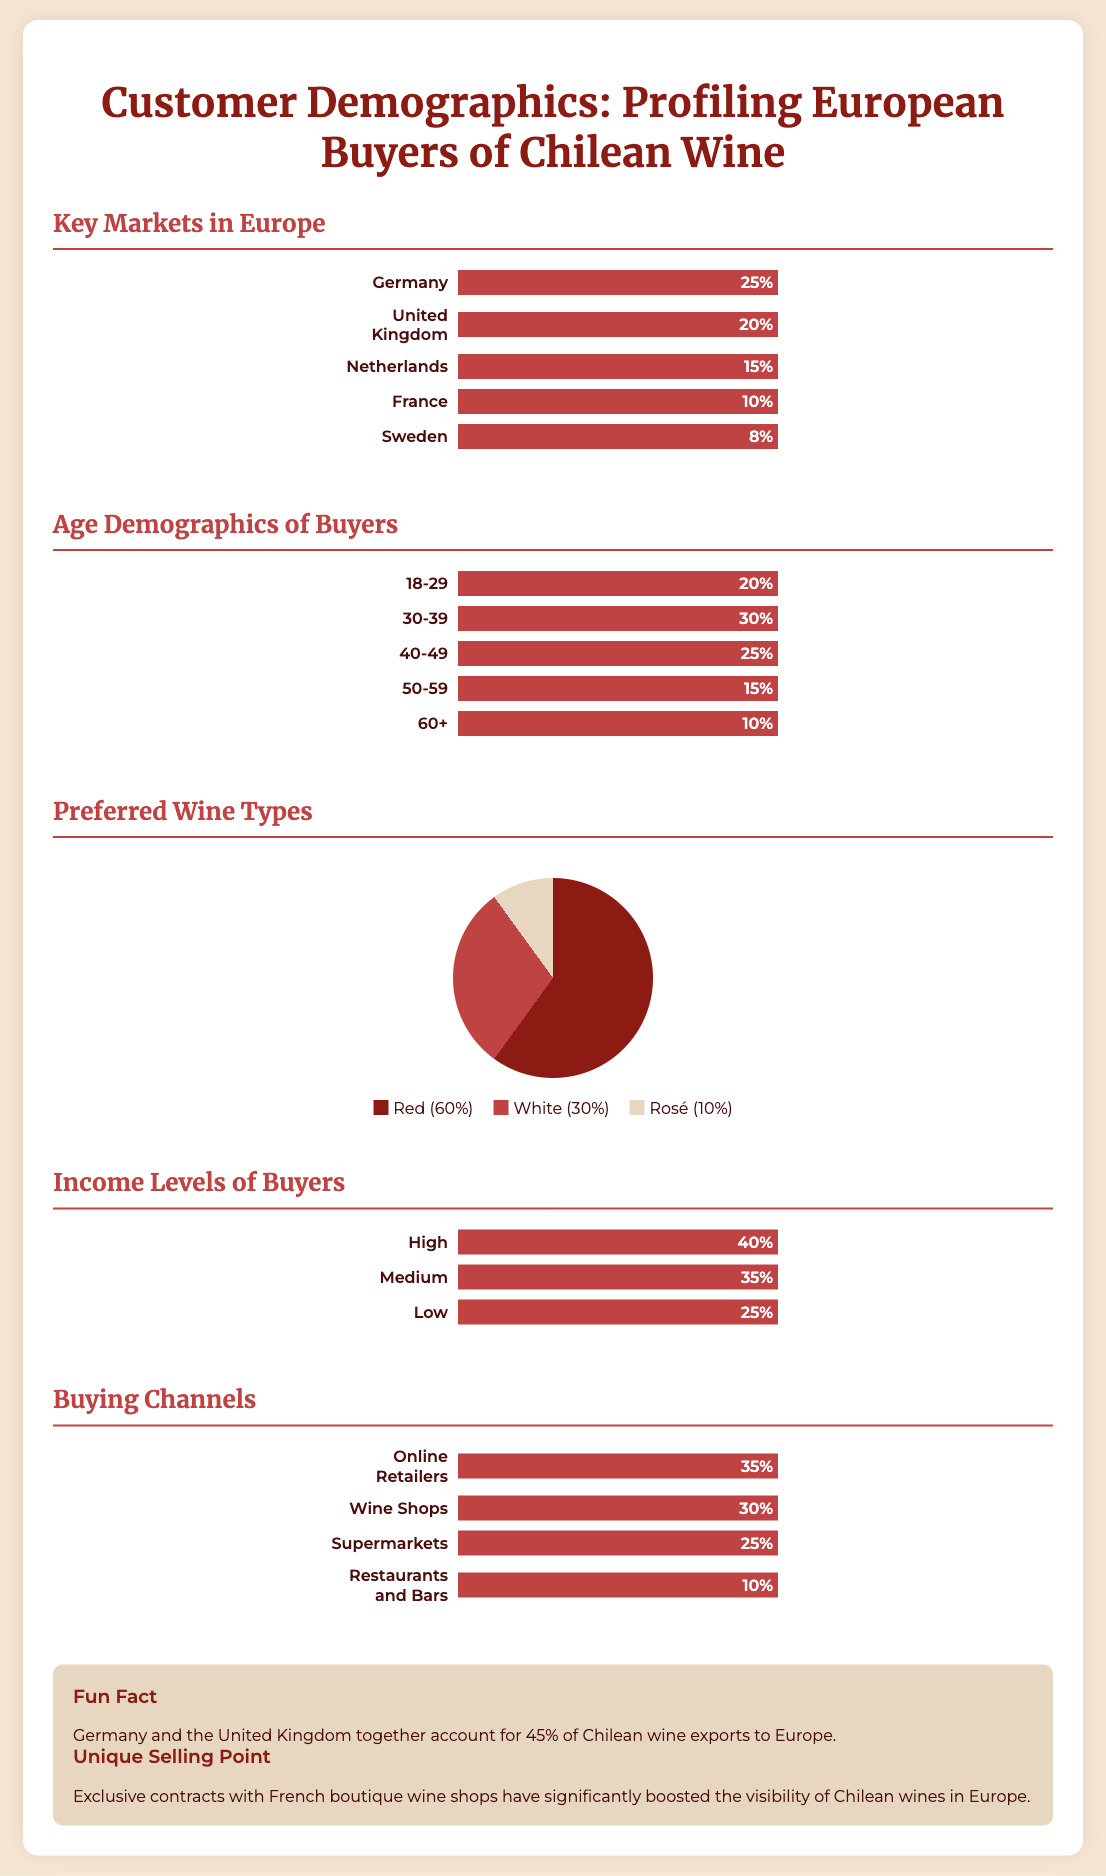What is the largest market for Chilean wine in Europe? The largest market is Germany, which accounts for 25% of buyers.
Answer: Germany What percentage of buyers are aged 30-39? The document states that 30% of buyers fall into the age range of 30-39.
Answer: 30% What type of wine is most preferred by European buyers? According to the infographic, red wine is the most preferred type at 60%.
Answer: Red What is the income level that represents the majority of buyers? The majority of buyers have a high income level, at 40%.
Answer: High Which buying channel has the least usage according to the data? The buying channel with the least usage is restaurants and bars, representing 10%.
Answer: Restaurants and Bars What unique selling point is highlighted in the document? The unique selling point mentioned is exclusive contracts with French boutique wine shops.
Answer: Exclusive contracts How much of the market do Germany and the UK represent collectively? Germany and the UK together account for 45% of the market.
Answer: 45% What percentage of buyers prefer white wine? The document indicates that 30% of buyers prefer white wine.
Answer: 30% What is the age group with the least representation among buyers? The age group with the least representation is 60+, accounting for 10%.
Answer: 60+ 